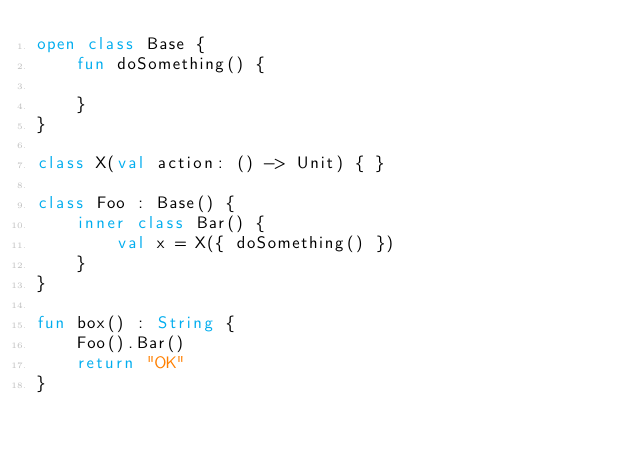<code> <loc_0><loc_0><loc_500><loc_500><_Kotlin_>open class Base {
    fun doSomething() {

    }
}

class X(val action: () -> Unit) { }

class Foo : Base() {
    inner class Bar() {
        val x = X({ doSomething() })
    }
}

fun box() : String {
    Foo().Bar()
    return "OK"
}
</code> 